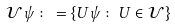<formula> <loc_0><loc_0><loc_500><loc_500>\mathcal { U } \psi \colon = \{ U \psi \colon U \in \mathcal { U } \}</formula> 